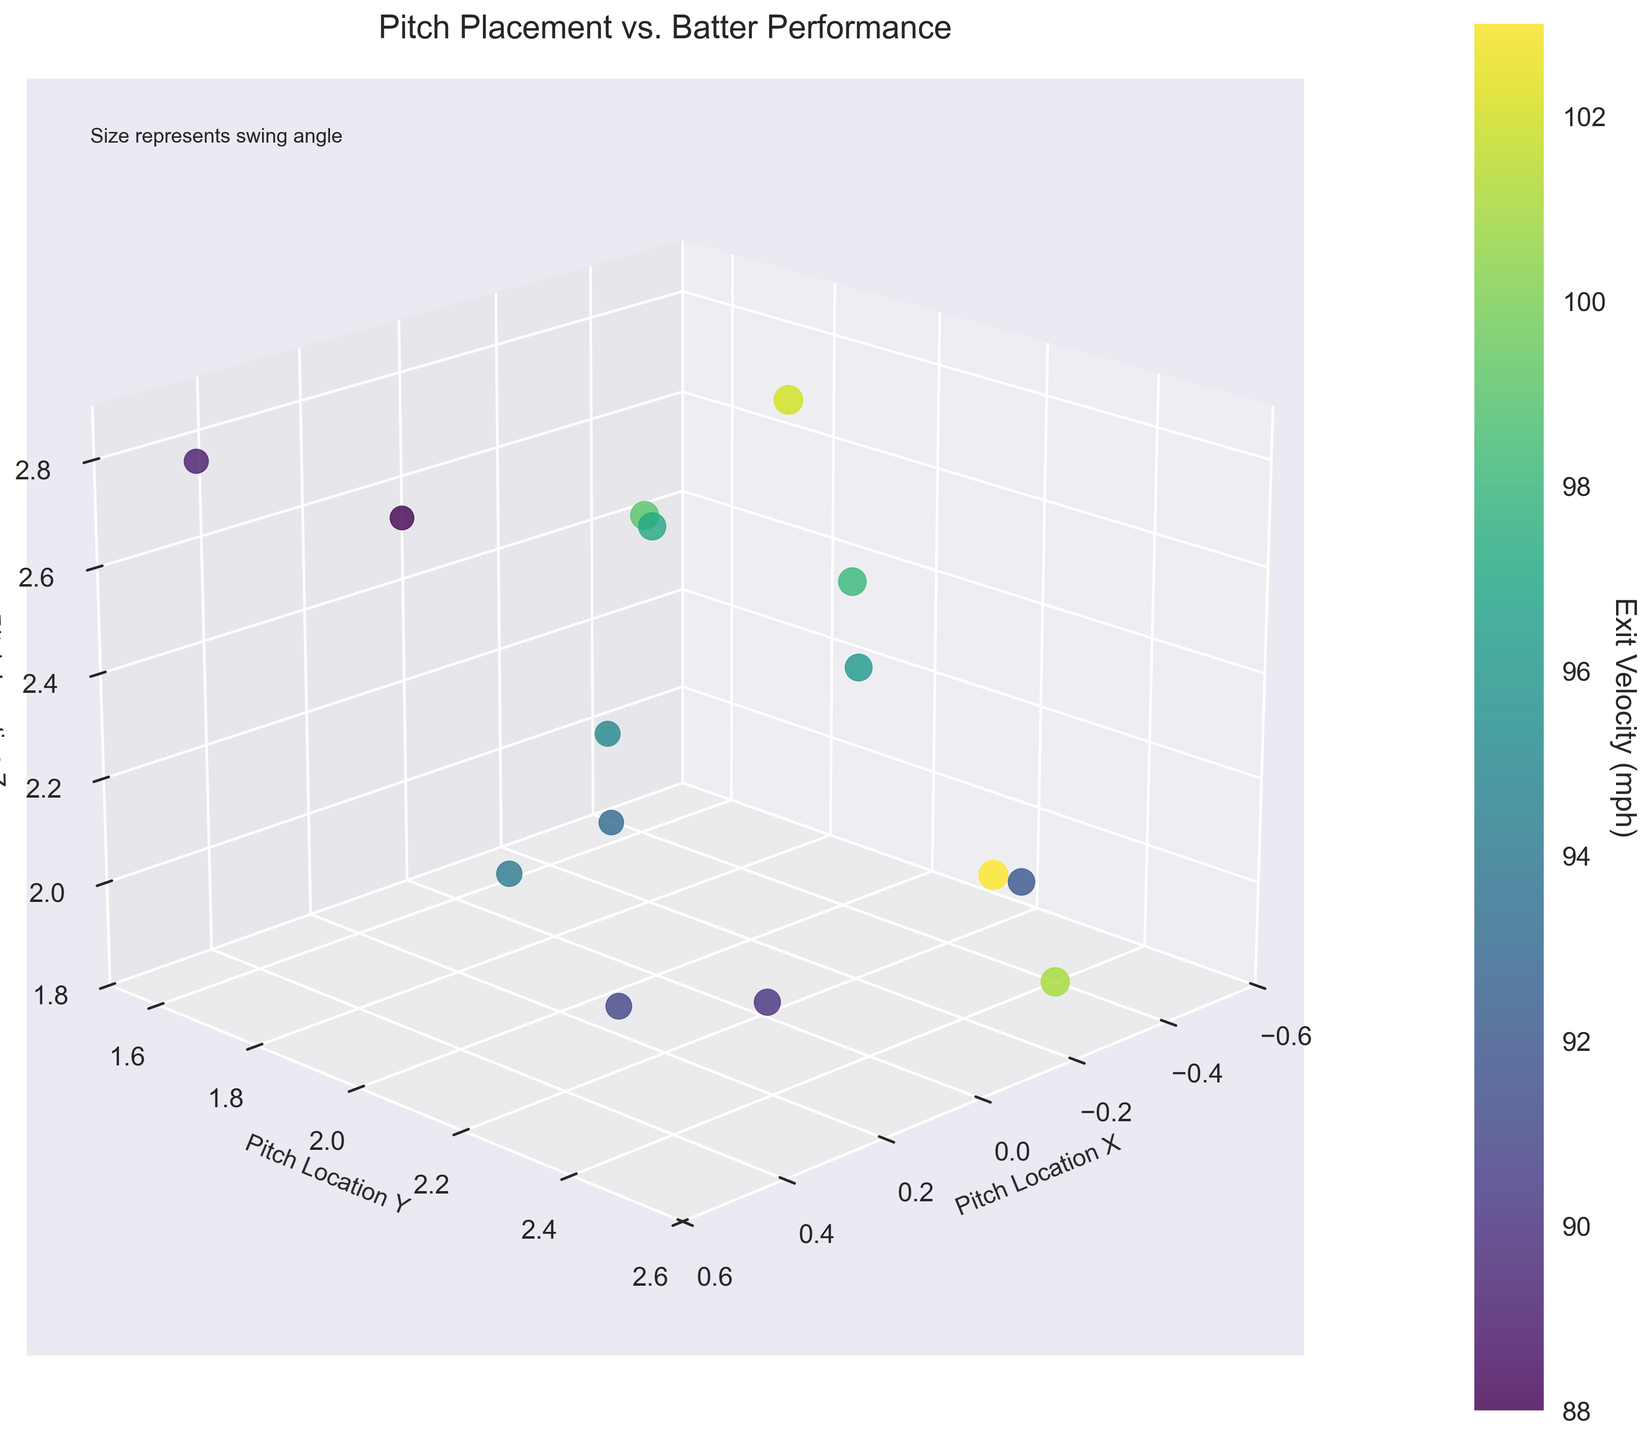What is the title of the figure? The title is usually placed at the top of the figure. Here, the title is "Pitch Placement vs. Batter Performance".
Answer: Pitch Placement vs. Batter Performance What color is used to represent the exit velocity in the plot? The color of data points changes with exit velocity, as indicated by the color bar labeled "Exit Velocity (mph)". It looks like a gradient transitioning through green to yellow, as the colormap used is 'viridis'.
Answer: Green to yellow How many axes are labeled, and what are they? The figure uses a 3D space, so there are three labeled axes. These are "Pitch Location X", "Pitch Location Y", and "Pitch Location Z". This information can be read directly from the axis labels on the plot.
Answer: Three axes: Pitch Location X, Pitch Location Y, Pitch Location Z What does the size of the data points represent? There is a note in the top left of the figure that says "Size represents swing angle". This means the bigger the data point, the larger the batter's swing angle.
Answer: Swing angle Which pitch location on the x-axis has the highest exit velocity? By referring to the color bar, the highest exit velocity will correspond to the yellowest data point. This point appears at about pitch_location_x = -0.5.
Answer: -0.5 What's the range of the pitch location on the y-axis? The y-axis is labeled "Pitch Location Y" and has limits set from 1.5 to 2.6, which can be seen directly beside the y-axis.
Answer: From 1.5 to 2.6 Is there a correlation between larger swing angles and higher exit velocities? To answer this, we observe the size of the data points (representing swing angles) and their corresponding colors (representing exit velocities). Generally, larger swing angles (bigger points) are associated with higher exit velocities (more yellowish colors).
Answer: Yes Compare the exit velocities for pitches located at pitch_location_x = -0.5, y = 2.2 and pitch_location_x = 0.5, y = 1.6. Which is greater? For pitch_location_x = -0.5, y = 2.2, the exit velocity is in the highest range (yellow). For pitch_location_x = 0.5, y = 1.6, the exit velocity is lower (greenish color). Comparing these, -0.5, y = 2.2 has a greater exit velocity.
Answer: The pitch at -0.5, y = 2.2 What pitch location (in x and z axes) has the smallest swing angle? Smaller swing angles correspond to smaller-sized data points. The smallest data points seem to be around pitch_location_x = 0.5, pitch_location_z = 2.8.
Answer: pitch_location_x = 0.5, pitch_location_z = 2.8 